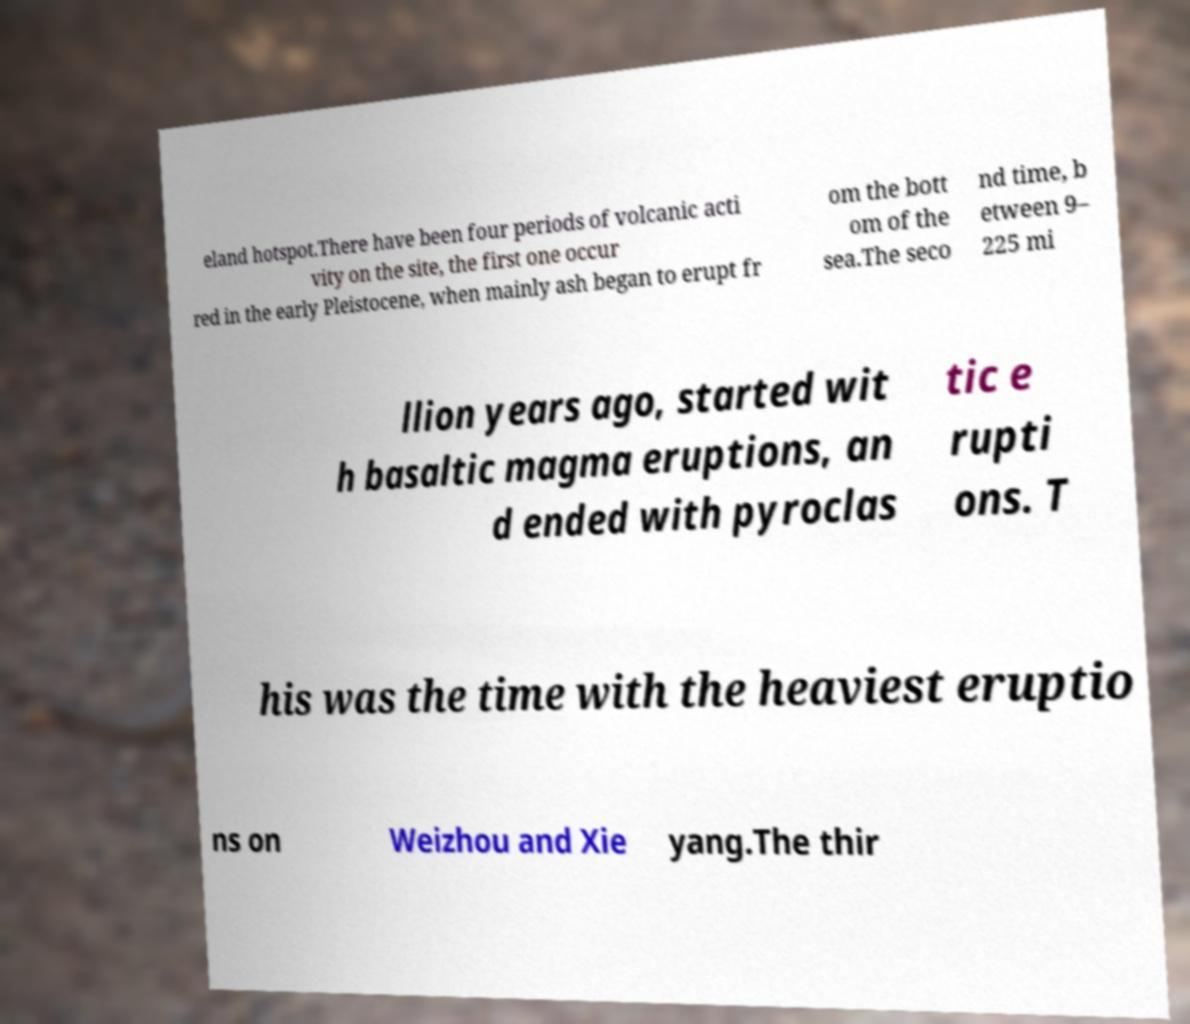For documentation purposes, I need the text within this image transcribed. Could you provide that? eland hotspot.There have been four periods of volcanic acti vity on the site, the first one occur red in the early Pleistocene, when mainly ash began to erupt fr om the bott om of the sea.The seco nd time, b etween 9– 225 mi llion years ago, started wit h basaltic magma eruptions, an d ended with pyroclas tic e rupti ons. T his was the time with the heaviest eruptio ns on Weizhou and Xie yang.The thir 